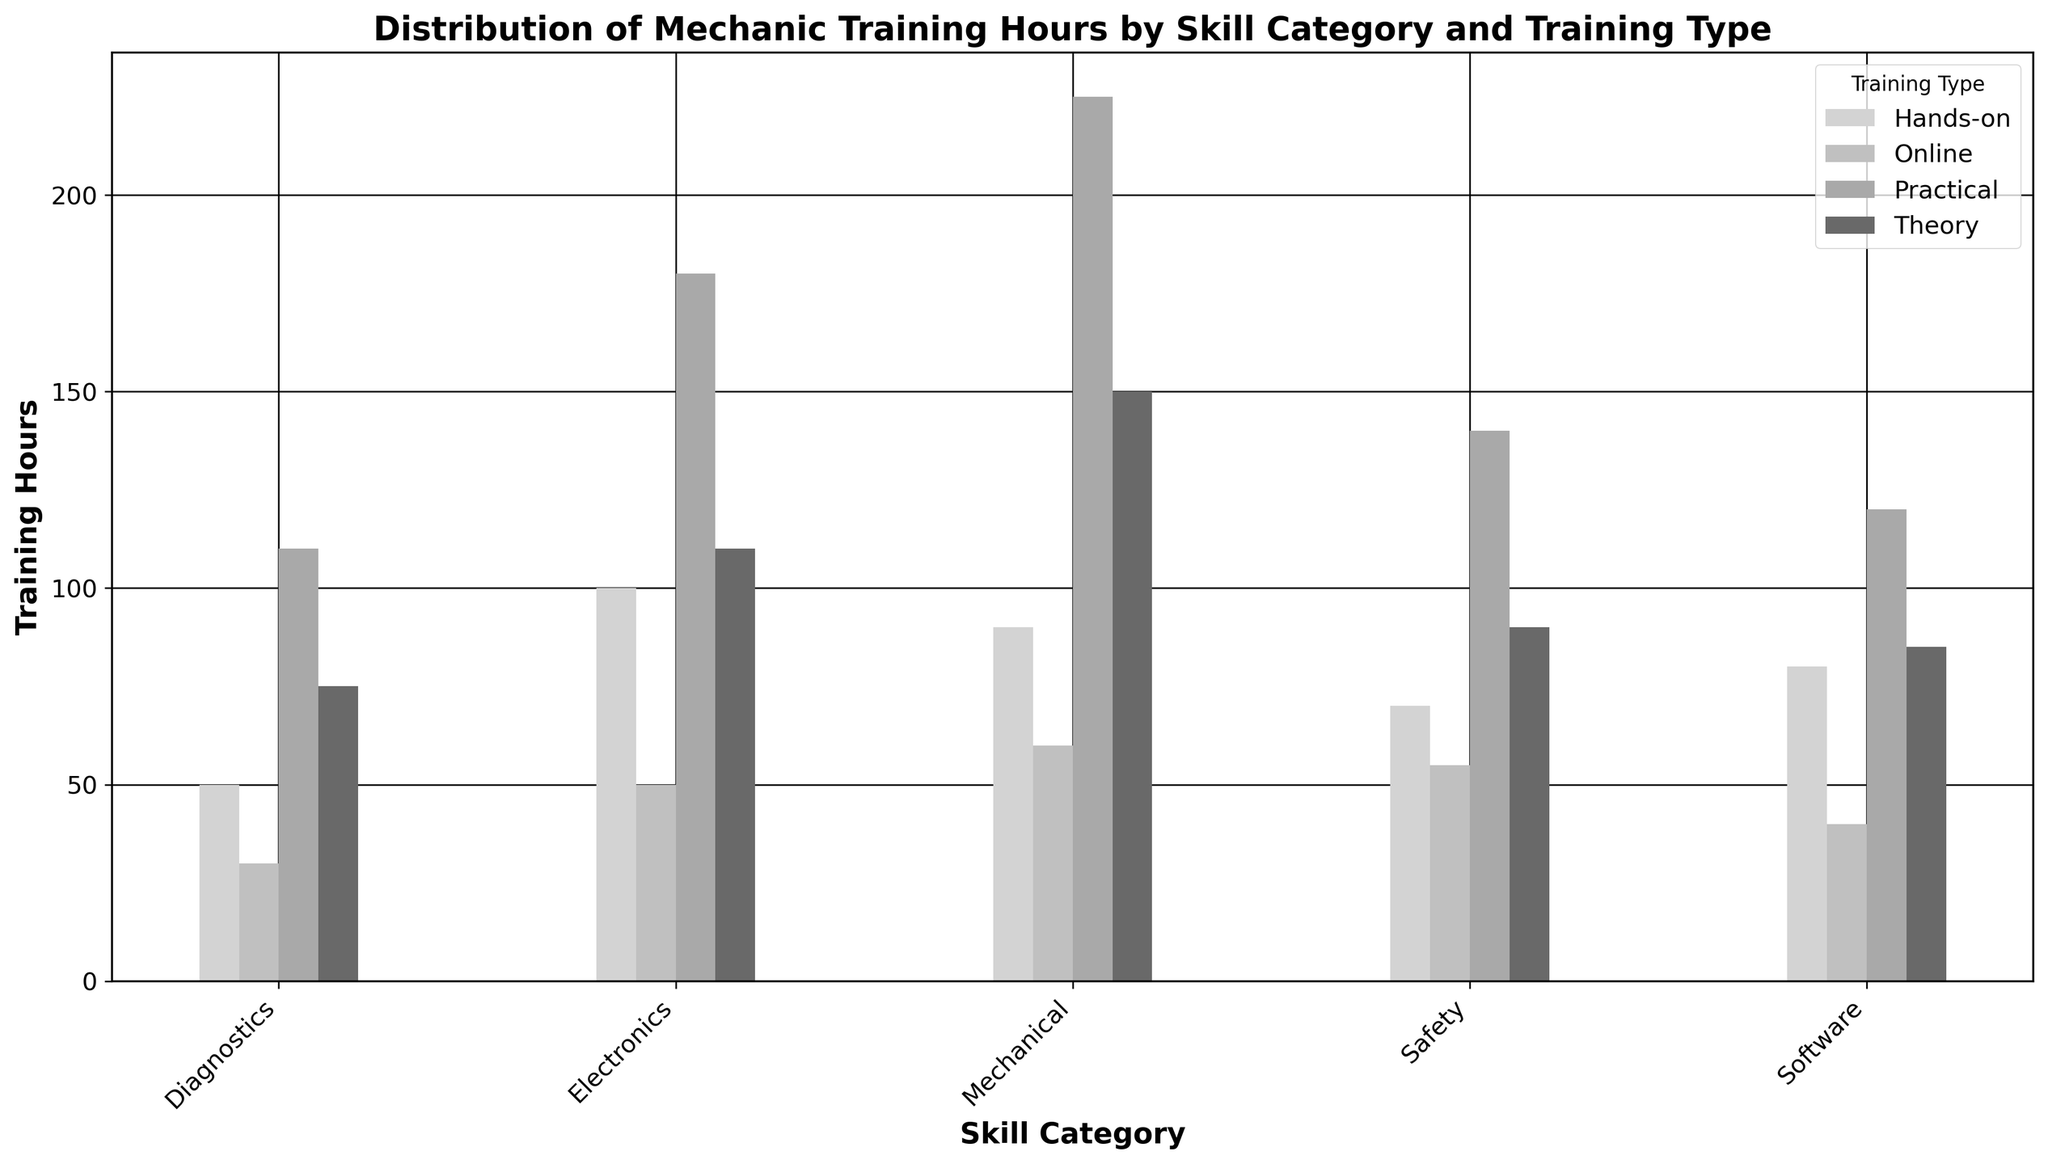Which skill category has the highest total training hours? To find the skill category with the highest total training hours, sum the hours across all training types for each category. Electronics: 110 + 180 + 50 + 100 = 440 hours; Software: 85 + 120 + 40 + 80 = 325 hours; Mechanical: 150 + 225 + 60 + 90 = 525 hours; Safety: 90 + 140 + 55 + 70 = 355 hours; Diagnostics: 75 + 110 + 30 + 50 = 265 hours. The skill category with the highest total is Mechanical.
Answer: Mechanical Which training type has the most cumulatively total hours across all skill categories? Sum the hours for each training type across all skill categories. Theory: 110 + 85 + 150 + 90 + 75 = 510 hours; Practical: 180 + 120 + 225 + 140 + 110 = 775 hours; Online: 50 + 40 + 60 + 55 + 30 = 235 hours; Hands-on: 100 + 80 + 90 + 70 + 50 = 390 hours. Practical training type has the highest total.
Answer: Practical What is the total training hours for Software skill category? Sum the training hours for all types within the Software skill category. 85 (Theory) + 120 (Practical) + 40 (Online) + 80 (Hands-on) = 325 hours.
Answer: 325 Between Electronics and Diagnostics, which has more Practical training hours? Compare Practical training hours for both Electronics and Diagnostics. Electronics has 180 hours and Diagnostics has 110 hours. Electronics has more Practical training hours.
Answer: Electronics How much more Practical training hours are there in Mechanical compared to Software? Subtract Practical training hours of Software from Mechanical. Mechanical has 225 hours and Software has 120 hours. 225 - 120 = 105 hours.
Answer: 105 Which skill category has the least Hands-on training hours? Compare the Hands-on training hours across all skill categories. Hands-on hours are Electronics: 100, Software: 80, Mechanical: 90, Safety: 70, and Diagnostics: 50. Diagnostics has the least Hands-on training hours with 50 hours.
Answer: Diagnostics What is the average number of Theory training hours per skill category? Sum the Theory training hours and divide by the number of skill categories. Total Theory hours: 110 + 85 + 150 + 90 + 75 = 510. Number of skill categories: 5. Average: 510 / 5 = 102 hours.
Answer: 102 How do the Online training hours for Safety compare to Online training hours for Mechanical? Compare the Online training hours directly. Safety has 55 hours, Mechanical has 60 hours. Safety has 5 hours less than Mechanical.
Answer: Safety has 5 fewer hours Which training type has the second highest hours in the Mechanical category? Review the training hours within the Mechanical category: Theory (150), Practical (225), Online (60), Hands-on (90). Theory has the second highest hours after Practical.
Answer: Theory What is the total of Online and Hands-on training combined across all skill categories? Sum the Online and Hands-on training hours across all skill categories. Online: 50 + 40 + 60 + 55 + 30 = 235. Hands-on: 100 + 80 + 90 + 70 + 50 = 390. Combined Total: 235 + 390 = 625 hours.
Answer: 625 